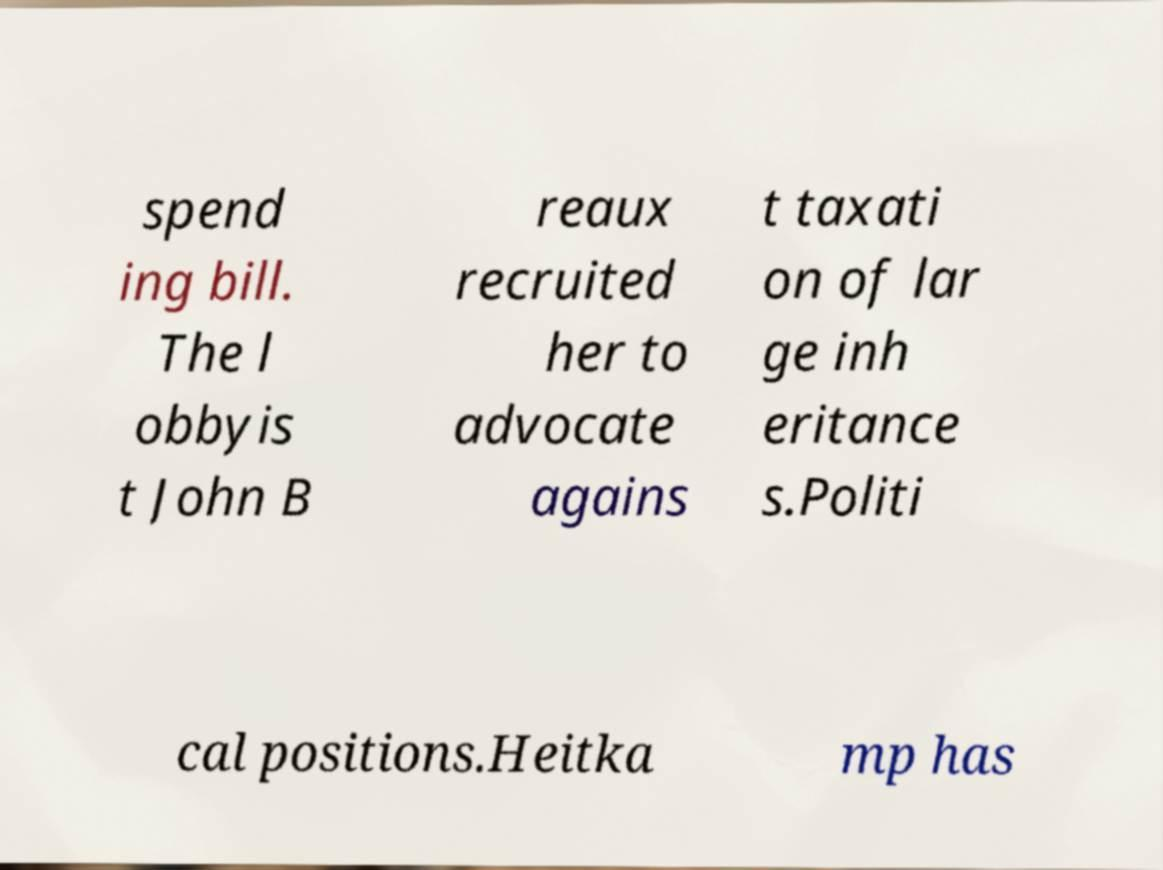Can you accurately transcribe the text from the provided image for me? spend ing bill. The l obbyis t John B reaux recruited her to advocate agains t taxati on of lar ge inh eritance s.Politi cal positions.Heitka mp has 